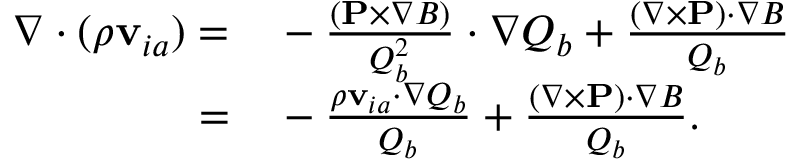Convert formula to latex. <formula><loc_0><loc_0><loc_500><loc_500>\begin{array} { r l } { \nabla \cdot ( \rho { v } _ { i a } ) = } & - \frac { ( { P } \times \nabla B ) } { Q _ { b } ^ { 2 } } \cdot \nabla Q _ { b } + \frac { ( \nabla \times { P } ) \cdot \nabla B } { Q _ { b } } } \\ { = } & - \frac { \rho { v } _ { i a } \cdot \nabla Q _ { b } } { Q _ { b } } + \frac { ( \nabla \times { P } ) \cdot \nabla B } { Q _ { b } } . } \end{array}</formula> 